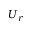Convert formula to latex. <formula><loc_0><loc_0><loc_500><loc_500>U _ { r }</formula> 